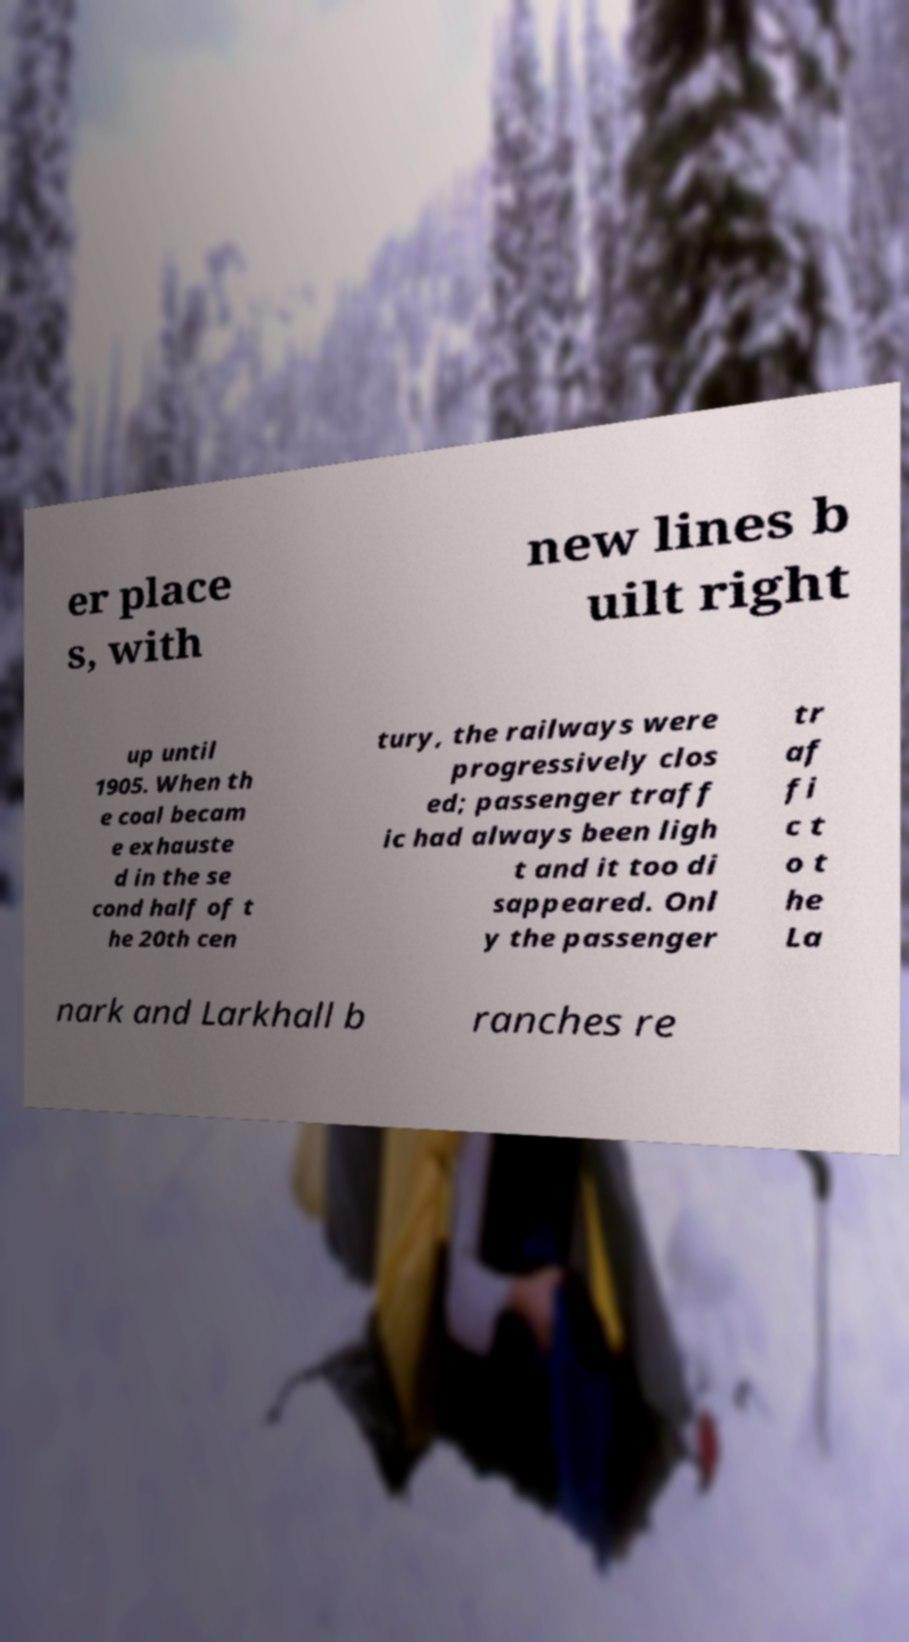I need the written content from this picture converted into text. Can you do that? er place s, with new lines b uilt right up until 1905. When th e coal becam e exhauste d in the se cond half of t he 20th cen tury, the railways were progressively clos ed; passenger traff ic had always been ligh t and it too di sappeared. Onl y the passenger tr af fi c t o t he La nark and Larkhall b ranches re 